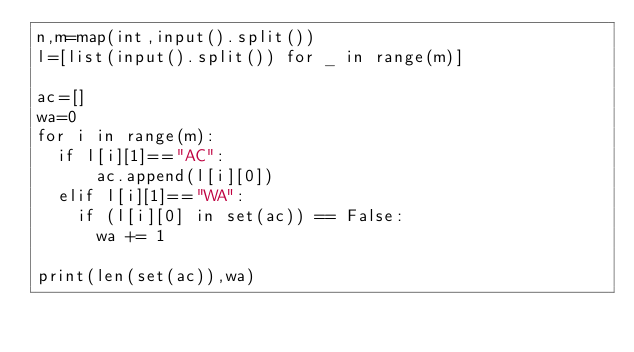Convert code to text. <code><loc_0><loc_0><loc_500><loc_500><_Python_>n,m=map(int,input().split())
l=[list(input().split()) for _ in range(m)]
 
ac=[]
wa=0
for i in range(m):
  if l[i][1]=="AC":
      ac.append(l[i][0])
  elif l[i][1]=="WA":
    if (l[i][0] in set(ac)) == False:
      wa += 1
    
print(len(set(ac)),wa)</code> 